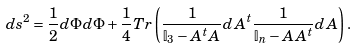Convert formula to latex. <formula><loc_0><loc_0><loc_500><loc_500>d s ^ { 2 } = \frac { 1 } { 2 } d \Phi d \Phi + \frac { 1 } { 4 } T r \left ( \frac { 1 } { \mathbb { I } _ { 3 } - A ^ { t } A } d A ^ { t } \frac { 1 } { \mathbb { I } _ { n } - A A ^ { t } } d A \right ) .</formula> 